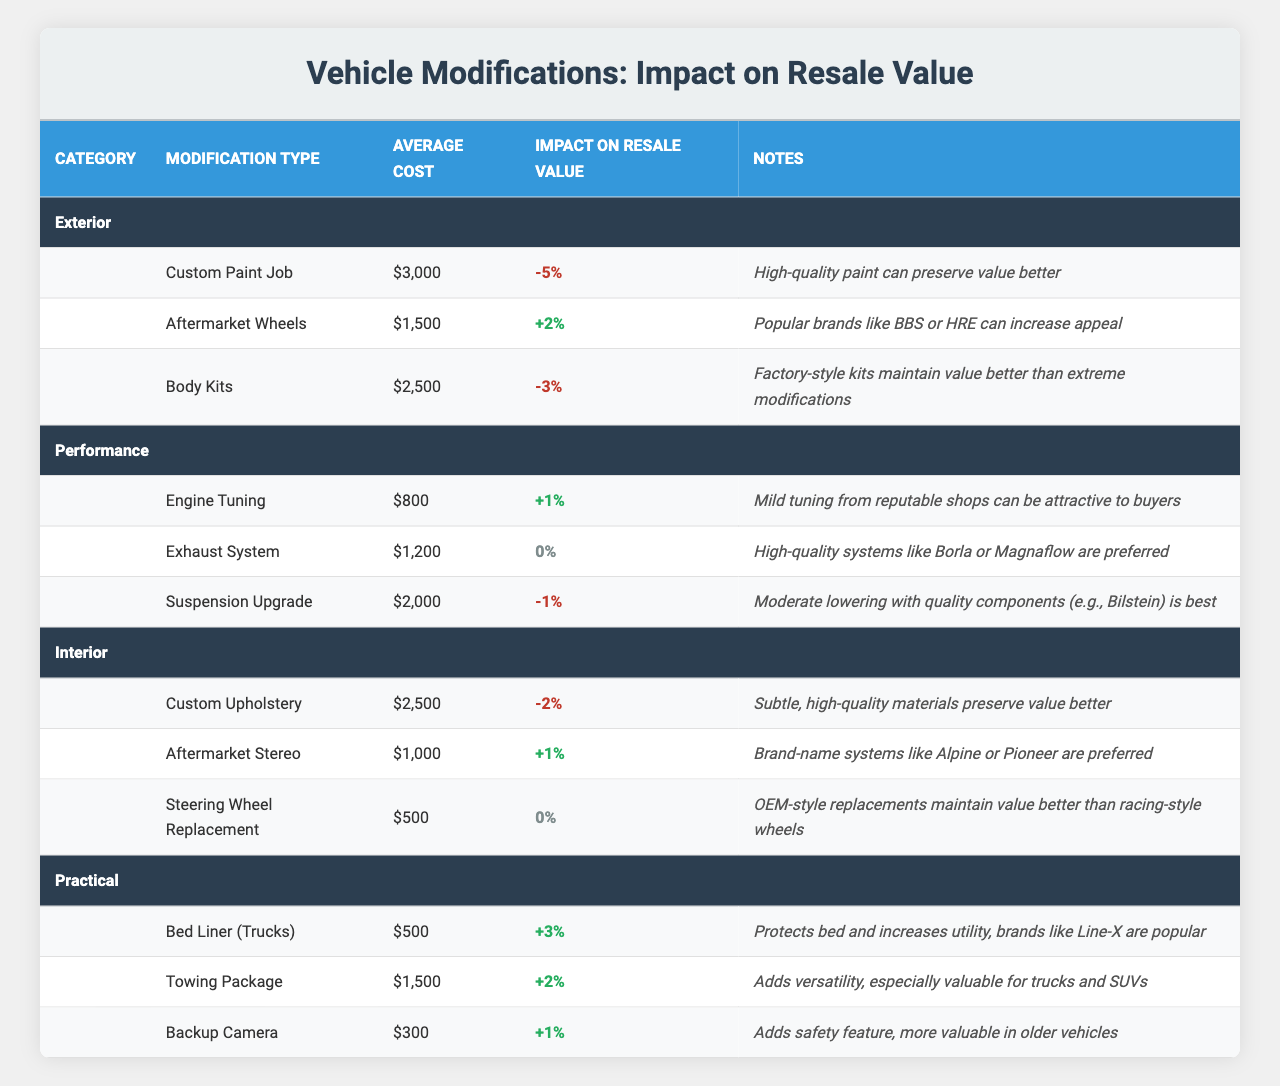What is the average cost of the "Custom Paint Job"? The table indicates that the average cost of the "Custom Paint Job" is listed directly under the "Average Cost" column corresponding to that modification. It shows $3,000.
Answer: $3,000 Which modification has the highest impact on resale value? A review of the "Impact on Resale Value" column for all modifications shows "Bed Liner (Trucks)" with an impact of +3%, which is the highest value.
Answer: Bed Liner (Trucks) Do aftermarket wheels increase or decrease resale value? According to the "Impact on Resale Value" column, aftermarket wheels have a +2%, indicating they increase resale value.
Answer: Increase Which exterior modification has the most positive impact on resale value? Analyzing the "Exterior" category's modifications, "Aftermarket Wheels" shows +2%, which is the highest positive impact among others like -5% and -3%.
Answer: Aftermarket Wheels What is the total average cost of all performance modifications? The average costs are Engine Tuning ($800), Exhaust System ($1,200), and Suspension Upgrade ($2,000). Summing these gives $800 + $1,200 + $2,000 = $4,000.
Answer: $4,000 Are engine tunings generally seen as a good investment for resale value? The "Impact on Resale Value" for "Engine Tuning" shows +1%, indicating a slight positive effect, which suggests it can be a good investment, though not major.
Answer: Yes If you add a towing package to a vehicle, how much would it potentially increase the resale value? The table states that the "Towing Package" has a potential increase in resale value of +2%, meaning it adds that percentage to the overall vehicle value.
Answer: +2% Which modification category has the highest average impact on resale value? By reviewing each modification in the table, the "Practical" category's average increases (+3%, +2%, +1%) compared to other categories, which have negatives. Calculating the average gives us +2%.
Answer: Practical Which modification type is least favorable for resale value? Within the table, comparing every modification, "Custom Paint Job" shows the most negative impact at -5%, indicating it is the least favorable for resale value.
Answer: Custom Paint Job Is the average cost of custom upholstery higher or lower than the average cost of aftermarket wheels? Custom Upholstery has an average cost of $2,500 while aftermarket wheels cost $1,500. When comparing, $2,500 is higher than $1,500.
Answer: Higher 